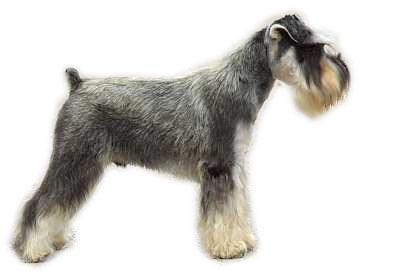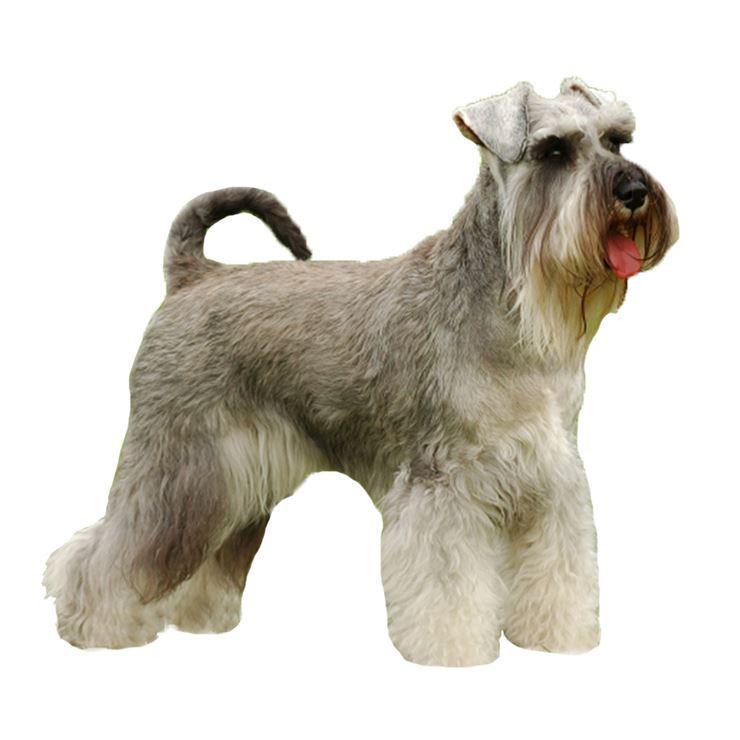The first image is the image on the left, the second image is the image on the right. Evaluate the accuracy of this statement regarding the images: "All dogs are facing to the left.". Is it true? Answer yes or no. No. 